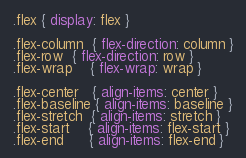<code> <loc_0><loc_0><loc_500><loc_500><_CSS_>
.flex { display: flex }

.flex-column  { flex-direction: column }
.flex-row  { flex-direction: row }
.flex-wrap    { flex-wrap: wrap }

.flex-center   { align-items: center }
.flex-baseline { align-items: baseline }
.flex-stretch  { align-items: stretch }
.flex-start    { align-items: flex-start }
.flex-end      { align-items: flex-end }
</code> 